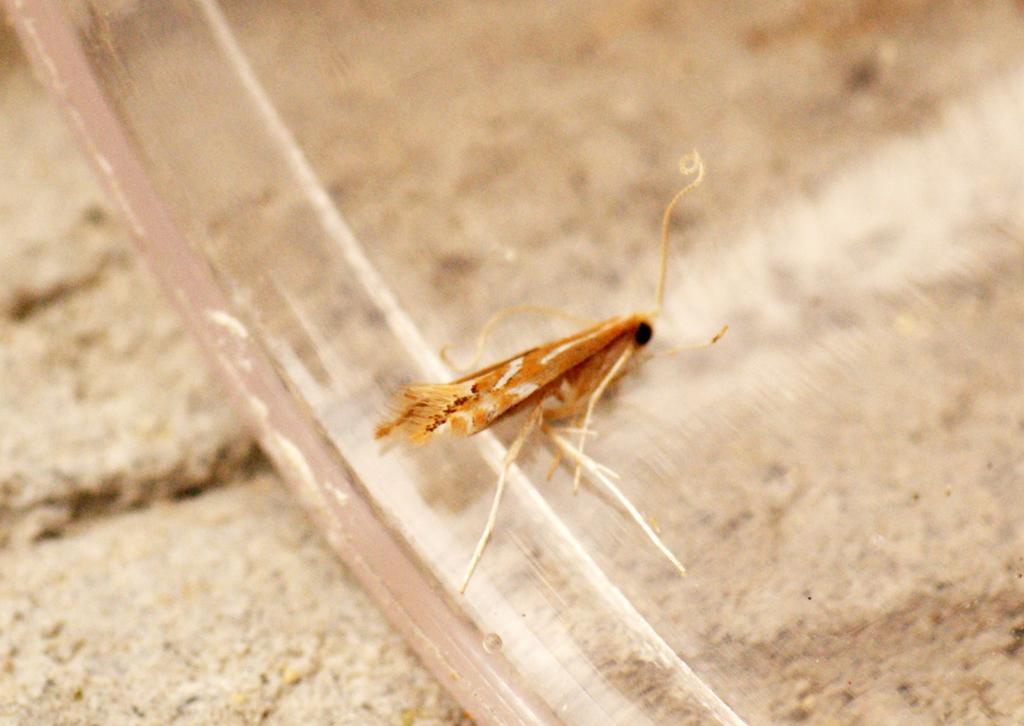Describe this image in one or two sentences. In this image there is an insect on the object which is on the land. 